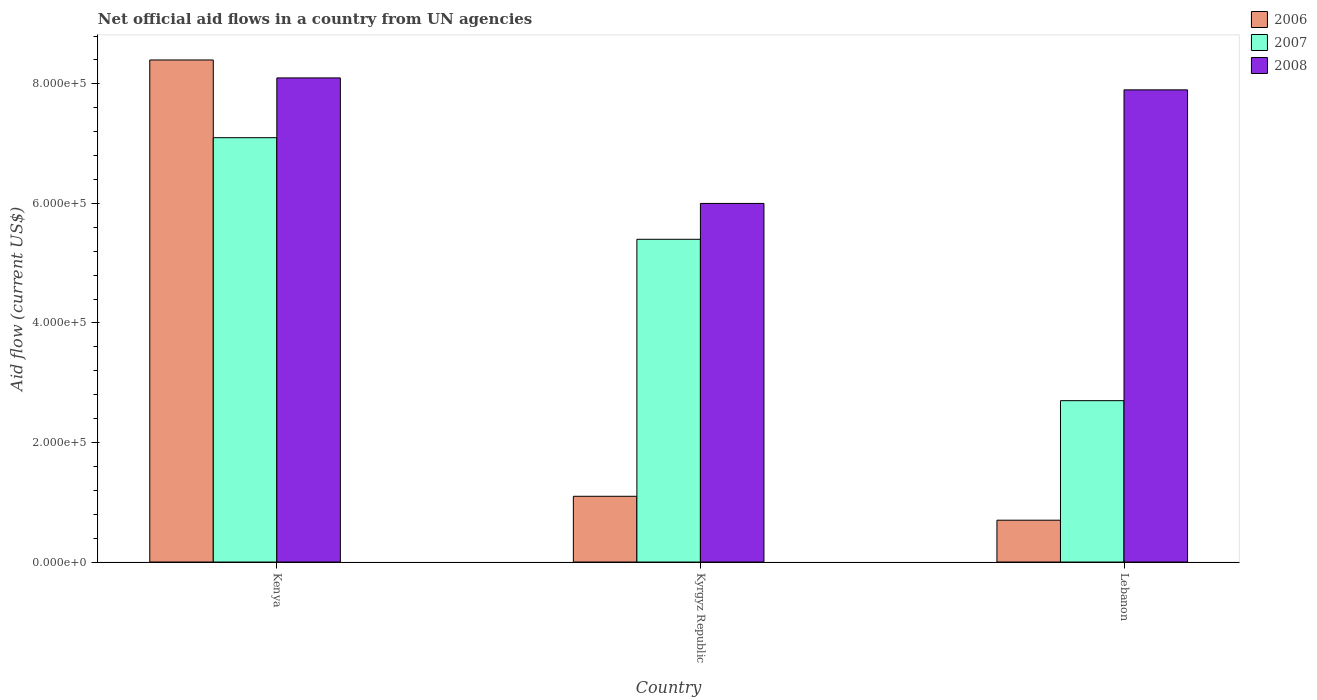How many different coloured bars are there?
Your answer should be very brief. 3. How many bars are there on the 3rd tick from the right?
Your answer should be very brief. 3. What is the label of the 3rd group of bars from the left?
Give a very brief answer. Lebanon. What is the net official aid flow in 2008 in Lebanon?
Ensure brevity in your answer.  7.90e+05. Across all countries, what is the maximum net official aid flow in 2008?
Offer a terse response. 8.10e+05. In which country was the net official aid flow in 2007 maximum?
Keep it short and to the point. Kenya. In which country was the net official aid flow in 2006 minimum?
Provide a short and direct response. Lebanon. What is the total net official aid flow in 2006 in the graph?
Your response must be concise. 1.02e+06. What is the difference between the net official aid flow in 2007 in Kyrgyz Republic and that in Lebanon?
Offer a very short reply. 2.70e+05. What is the difference between the net official aid flow in 2008 in Kyrgyz Republic and the net official aid flow in 2006 in Lebanon?
Offer a very short reply. 5.30e+05. What is the difference between the net official aid flow of/in 2006 and net official aid flow of/in 2008 in Lebanon?
Your answer should be very brief. -7.20e+05. What is the ratio of the net official aid flow in 2008 in Kyrgyz Republic to that in Lebanon?
Keep it short and to the point. 0.76. Is the difference between the net official aid flow in 2006 in Kyrgyz Republic and Lebanon greater than the difference between the net official aid flow in 2008 in Kyrgyz Republic and Lebanon?
Your response must be concise. Yes. In how many countries, is the net official aid flow in 2007 greater than the average net official aid flow in 2007 taken over all countries?
Your answer should be very brief. 2. Is the sum of the net official aid flow in 2008 in Kenya and Kyrgyz Republic greater than the maximum net official aid flow in 2006 across all countries?
Your answer should be compact. Yes. How many bars are there?
Make the answer very short. 9. What is the difference between two consecutive major ticks on the Y-axis?
Offer a very short reply. 2.00e+05. Are the values on the major ticks of Y-axis written in scientific E-notation?
Your answer should be very brief. Yes. Does the graph contain grids?
Offer a very short reply. No. Where does the legend appear in the graph?
Offer a very short reply. Top right. What is the title of the graph?
Offer a very short reply. Net official aid flows in a country from UN agencies. Does "1989" appear as one of the legend labels in the graph?
Offer a terse response. No. What is the label or title of the X-axis?
Make the answer very short. Country. What is the label or title of the Y-axis?
Your response must be concise. Aid flow (current US$). What is the Aid flow (current US$) in 2006 in Kenya?
Keep it short and to the point. 8.40e+05. What is the Aid flow (current US$) in 2007 in Kenya?
Give a very brief answer. 7.10e+05. What is the Aid flow (current US$) in 2008 in Kenya?
Provide a succinct answer. 8.10e+05. What is the Aid flow (current US$) in 2006 in Kyrgyz Republic?
Provide a short and direct response. 1.10e+05. What is the Aid flow (current US$) of 2007 in Kyrgyz Republic?
Ensure brevity in your answer.  5.40e+05. What is the Aid flow (current US$) of 2008 in Kyrgyz Republic?
Ensure brevity in your answer.  6.00e+05. What is the Aid flow (current US$) in 2008 in Lebanon?
Ensure brevity in your answer.  7.90e+05. Across all countries, what is the maximum Aid flow (current US$) of 2006?
Your answer should be compact. 8.40e+05. Across all countries, what is the maximum Aid flow (current US$) in 2007?
Keep it short and to the point. 7.10e+05. Across all countries, what is the maximum Aid flow (current US$) of 2008?
Make the answer very short. 8.10e+05. Across all countries, what is the minimum Aid flow (current US$) of 2006?
Provide a succinct answer. 7.00e+04. Across all countries, what is the minimum Aid flow (current US$) in 2007?
Provide a short and direct response. 2.70e+05. Across all countries, what is the minimum Aid flow (current US$) of 2008?
Ensure brevity in your answer.  6.00e+05. What is the total Aid flow (current US$) of 2006 in the graph?
Offer a very short reply. 1.02e+06. What is the total Aid flow (current US$) of 2007 in the graph?
Your answer should be very brief. 1.52e+06. What is the total Aid flow (current US$) in 2008 in the graph?
Provide a succinct answer. 2.20e+06. What is the difference between the Aid flow (current US$) in 2006 in Kenya and that in Kyrgyz Republic?
Keep it short and to the point. 7.30e+05. What is the difference between the Aid flow (current US$) of 2008 in Kenya and that in Kyrgyz Republic?
Make the answer very short. 2.10e+05. What is the difference between the Aid flow (current US$) of 2006 in Kenya and that in Lebanon?
Provide a succinct answer. 7.70e+05. What is the difference between the Aid flow (current US$) of 2007 in Kenya and that in Lebanon?
Your response must be concise. 4.40e+05. What is the difference between the Aid flow (current US$) in 2008 in Kenya and that in Lebanon?
Your response must be concise. 2.00e+04. What is the difference between the Aid flow (current US$) in 2007 in Kyrgyz Republic and that in Lebanon?
Give a very brief answer. 2.70e+05. What is the difference between the Aid flow (current US$) in 2006 in Kenya and the Aid flow (current US$) in 2007 in Kyrgyz Republic?
Make the answer very short. 3.00e+05. What is the difference between the Aid flow (current US$) of 2006 in Kenya and the Aid flow (current US$) of 2008 in Kyrgyz Republic?
Your response must be concise. 2.40e+05. What is the difference between the Aid flow (current US$) in 2007 in Kenya and the Aid flow (current US$) in 2008 in Kyrgyz Republic?
Give a very brief answer. 1.10e+05. What is the difference between the Aid flow (current US$) of 2006 in Kenya and the Aid flow (current US$) of 2007 in Lebanon?
Ensure brevity in your answer.  5.70e+05. What is the difference between the Aid flow (current US$) in 2007 in Kenya and the Aid flow (current US$) in 2008 in Lebanon?
Make the answer very short. -8.00e+04. What is the difference between the Aid flow (current US$) in 2006 in Kyrgyz Republic and the Aid flow (current US$) in 2008 in Lebanon?
Ensure brevity in your answer.  -6.80e+05. What is the difference between the Aid flow (current US$) in 2007 in Kyrgyz Republic and the Aid flow (current US$) in 2008 in Lebanon?
Provide a short and direct response. -2.50e+05. What is the average Aid flow (current US$) of 2007 per country?
Offer a terse response. 5.07e+05. What is the average Aid flow (current US$) of 2008 per country?
Your answer should be very brief. 7.33e+05. What is the difference between the Aid flow (current US$) in 2007 and Aid flow (current US$) in 2008 in Kenya?
Keep it short and to the point. -1.00e+05. What is the difference between the Aid flow (current US$) of 2006 and Aid flow (current US$) of 2007 in Kyrgyz Republic?
Ensure brevity in your answer.  -4.30e+05. What is the difference between the Aid flow (current US$) in 2006 and Aid flow (current US$) in 2008 in Kyrgyz Republic?
Provide a succinct answer. -4.90e+05. What is the difference between the Aid flow (current US$) in 2007 and Aid flow (current US$) in 2008 in Kyrgyz Republic?
Provide a succinct answer. -6.00e+04. What is the difference between the Aid flow (current US$) of 2006 and Aid flow (current US$) of 2008 in Lebanon?
Give a very brief answer. -7.20e+05. What is the difference between the Aid flow (current US$) in 2007 and Aid flow (current US$) in 2008 in Lebanon?
Your answer should be compact. -5.20e+05. What is the ratio of the Aid flow (current US$) of 2006 in Kenya to that in Kyrgyz Republic?
Your answer should be compact. 7.64. What is the ratio of the Aid flow (current US$) in 2007 in Kenya to that in Kyrgyz Republic?
Keep it short and to the point. 1.31. What is the ratio of the Aid flow (current US$) in 2008 in Kenya to that in Kyrgyz Republic?
Your answer should be very brief. 1.35. What is the ratio of the Aid flow (current US$) in 2006 in Kenya to that in Lebanon?
Your answer should be compact. 12. What is the ratio of the Aid flow (current US$) of 2007 in Kenya to that in Lebanon?
Provide a succinct answer. 2.63. What is the ratio of the Aid flow (current US$) in 2008 in Kenya to that in Lebanon?
Your answer should be compact. 1.03. What is the ratio of the Aid flow (current US$) of 2006 in Kyrgyz Republic to that in Lebanon?
Give a very brief answer. 1.57. What is the ratio of the Aid flow (current US$) of 2008 in Kyrgyz Republic to that in Lebanon?
Your answer should be very brief. 0.76. What is the difference between the highest and the second highest Aid flow (current US$) of 2006?
Provide a short and direct response. 7.30e+05. What is the difference between the highest and the second highest Aid flow (current US$) of 2008?
Your response must be concise. 2.00e+04. What is the difference between the highest and the lowest Aid flow (current US$) in 2006?
Keep it short and to the point. 7.70e+05. What is the difference between the highest and the lowest Aid flow (current US$) in 2007?
Provide a short and direct response. 4.40e+05. 